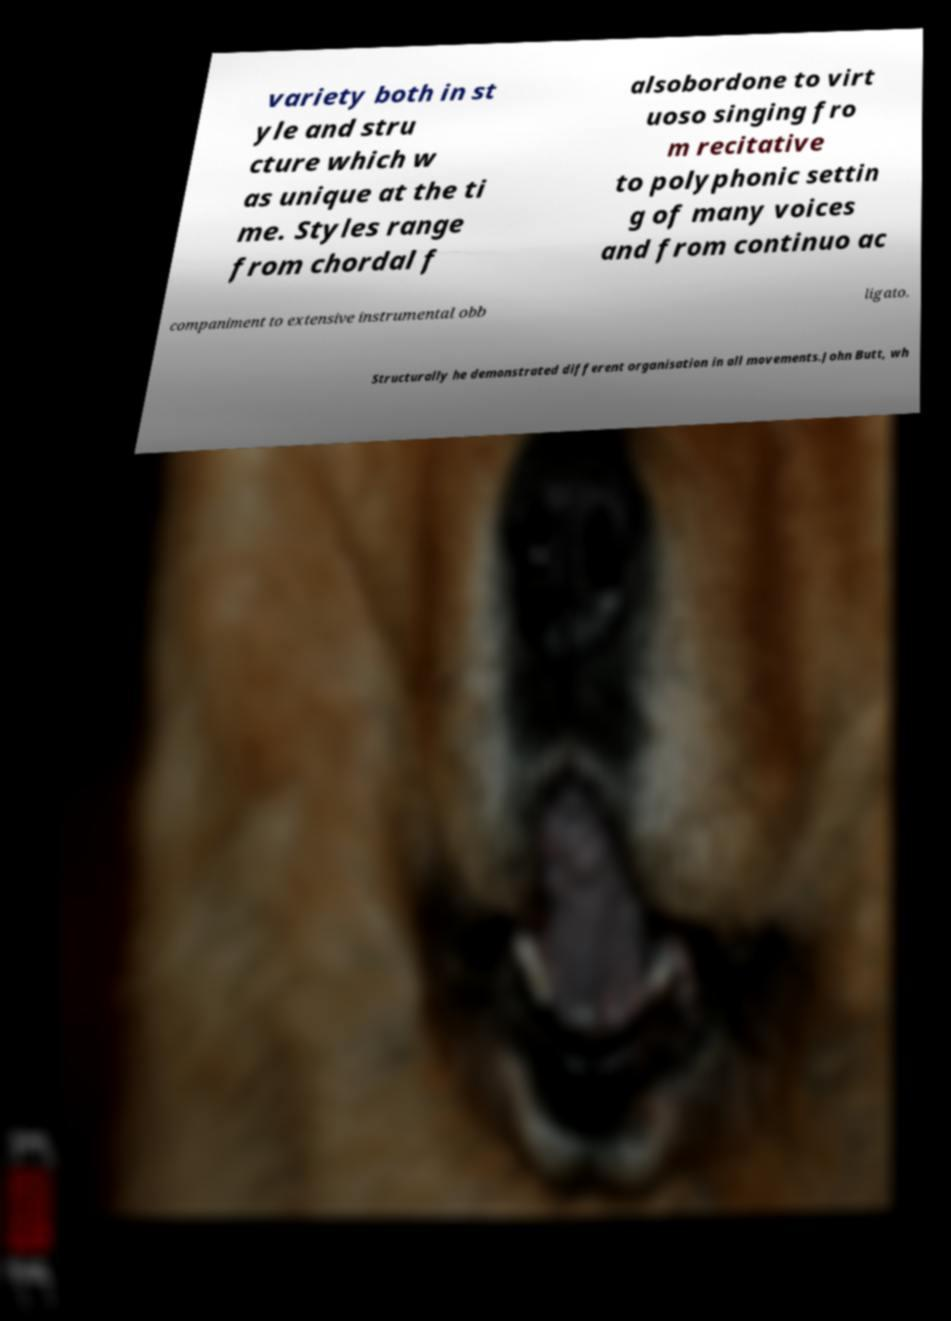Please identify and transcribe the text found in this image. variety both in st yle and stru cture which w as unique at the ti me. Styles range from chordal f alsobordone to virt uoso singing fro m recitative to polyphonic settin g of many voices and from continuo ac companiment to extensive instrumental obb ligato. Structurally he demonstrated different organisation in all movements.John Butt, wh 